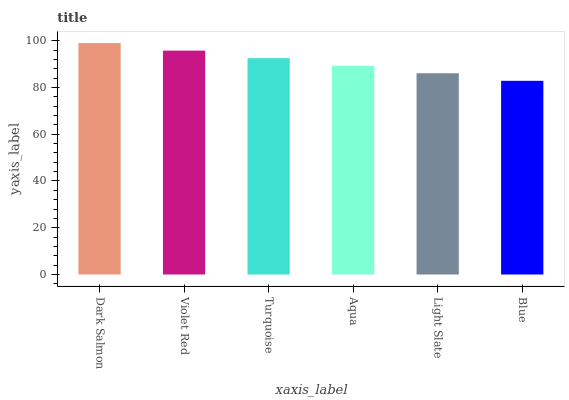Is Blue the minimum?
Answer yes or no. Yes. Is Dark Salmon the maximum?
Answer yes or no. Yes. Is Violet Red the minimum?
Answer yes or no. No. Is Violet Red the maximum?
Answer yes or no. No. Is Dark Salmon greater than Violet Red?
Answer yes or no. Yes. Is Violet Red less than Dark Salmon?
Answer yes or no. Yes. Is Violet Red greater than Dark Salmon?
Answer yes or no. No. Is Dark Salmon less than Violet Red?
Answer yes or no. No. Is Turquoise the high median?
Answer yes or no. Yes. Is Aqua the low median?
Answer yes or no. Yes. Is Violet Red the high median?
Answer yes or no. No. Is Blue the low median?
Answer yes or no. No. 